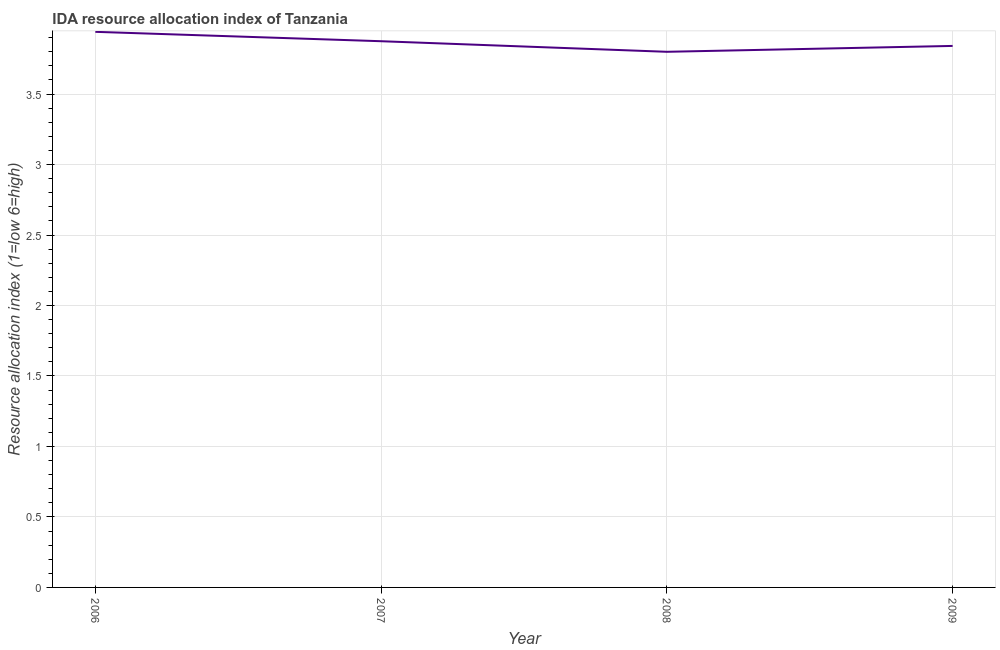What is the ida resource allocation index in 2008?
Your answer should be very brief. 3.8. Across all years, what is the maximum ida resource allocation index?
Your response must be concise. 3.94. Across all years, what is the minimum ida resource allocation index?
Give a very brief answer. 3.8. In which year was the ida resource allocation index maximum?
Make the answer very short. 2006. What is the sum of the ida resource allocation index?
Make the answer very short. 15.46. What is the difference between the ida resource allocation index in 2007 and 2008?
Make the answer very short. 0.08. What is the average ida resource allocation index per year?
Make the answer very short. 3.86. What is the median ida resource allocation index?
Your answer should be compact. 3.86. In how many years, is the ida resource allocation index greater than 2.9 ?
Offer a terse response. 4. Do a majority of the years between 2009 and 2006 (inclusive) have ida resource allocation index greater than 3.6 ?
Offer a very short reply. Yes. What is the ratio of the ida resource allocation index in 2007 to that in 2008?
Your response must be concise. 1.02. Is the ida resource allocation index in 2006 less than that in 2009?
Your response must be concise. No. Is the difference between the ida resource allocation index in 2007 and 2009 greater than the difference between any two years?
Offer a very short reply. No. What is the difference between the highest and the second highest ida resource allocation index?
Provide a succinct answer. 0.07. Is the sum of the ida resource allocation index in 2008 and 2009 greater than the maximum ida resource allocation index across all years?
Your answer should be compact. Yes. What is the difference between the highest and the lowest ida resource allocation index?
Make the answer very short. 0.14. Does the ida resource allocation index monotonically increase over the years?
Give a very brief answer. No. What is the difference between two consecutive major ticks on the Y-axis?
Your answer should be very brief. 0.5. Are the values on the major ticks of Y-axis written in scientific E-notation?
Your answer should be very brief. No. Does the graph contain any zero values?
Offer a terse response. No. Does the graph contain grids?
Offer a very short reply. Yes. What is the title of the graph?
Provide a short and direct response. IDA resource allocation index of Tanzania. What is the label or title of the X-axis?
Provide a succinct answer. Year. What is the label or title of the Y-axis?
Offer a terse response. Resource allocation index (1=low 6=high). What is the Resource allocation index (1=low 6=high) of 2006?
Provide a succinct answer. 3.94. What is the Resource allocation index (1=low 6=high) in 2007?
Provide a short and direct response. 3.88. What is the Resource allocation index (1=low 6=high) in 2008?
Offer a very short reply. 3.8. What is the Resource allocation index (1=low 6=high) in 2009?
Offer a very short reply. 3.84. What is the difference between the Resource allocation index (1=low 6=high) in 2006 and 2007?
Offer a terse response. 0.07. What is the difference between the Resource allocation index (1=low 6=high) in 2006 and 2008?
Your answer should be very brief. 0.14. What is the difference between the Resource allocation index (1=low 6=high) in 2006 and 2009?
Offer a very short reply. 0.1. What is the difference between the Resource allocation index (1=low 6=high) in 2007 and 2008?
Make the answer very short. 0.07. What is the difference between the Resource allocation index (1=low 6=high) in 2007 and 2009?
Your answer should be very brief. 0.03. What is the difference between the Resource allocation index (1=low 6=high) in 2008 and 2009?
Offer a very short reply. -0.04. What is the ratio of the Resource allocation index (1=low 6=high) in 2006 to that in 2008?
Your answer should be very brief. 1.04. What is the ratio of the Resource allocation index (1=low 6=high) in 2007 to that in 2008?
Offer a very short reply. 1.02. 